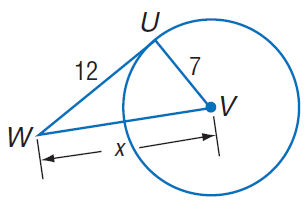Question: Find x. Assume that segments that appear to be tangent are tangent.
Choices:
A. 7
B. 12
C. \sqrt { 193 }
D. 14
Answer with the letter. Answer: C 